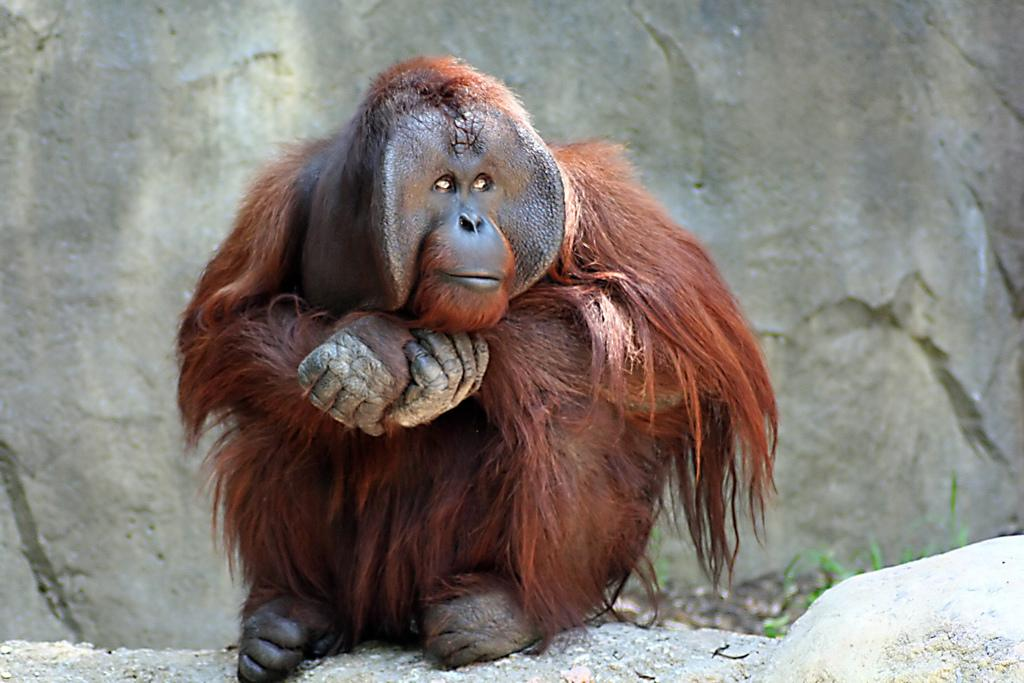What type of animal is in the image? There is an orangutan in the image. What is the orangutan doing in the image? The orangutan is sitting on the ground. What can be seen in the background of the image? There is grass visible in the background of the image. Who is the owner of the iron in the image? There is no iron present in the image. 